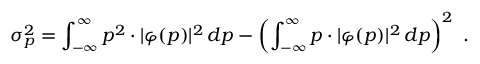Convert formula to latex. <formula><loc_0><loc_0><loc_500><loc_500>\sigma _ { p } ^ { 2 } = \int _ { - \infty } ^ { \infty } p ^ { 2 } \cdot | \varphi ( p ) | ^ { 2 } \, d p - \left ( \int _ { - \infty } ^ { \infty } p \cdot | \varphi ( p ) | ^ { 2 } \, d p \right ) ^ { 2 } .</formula> 